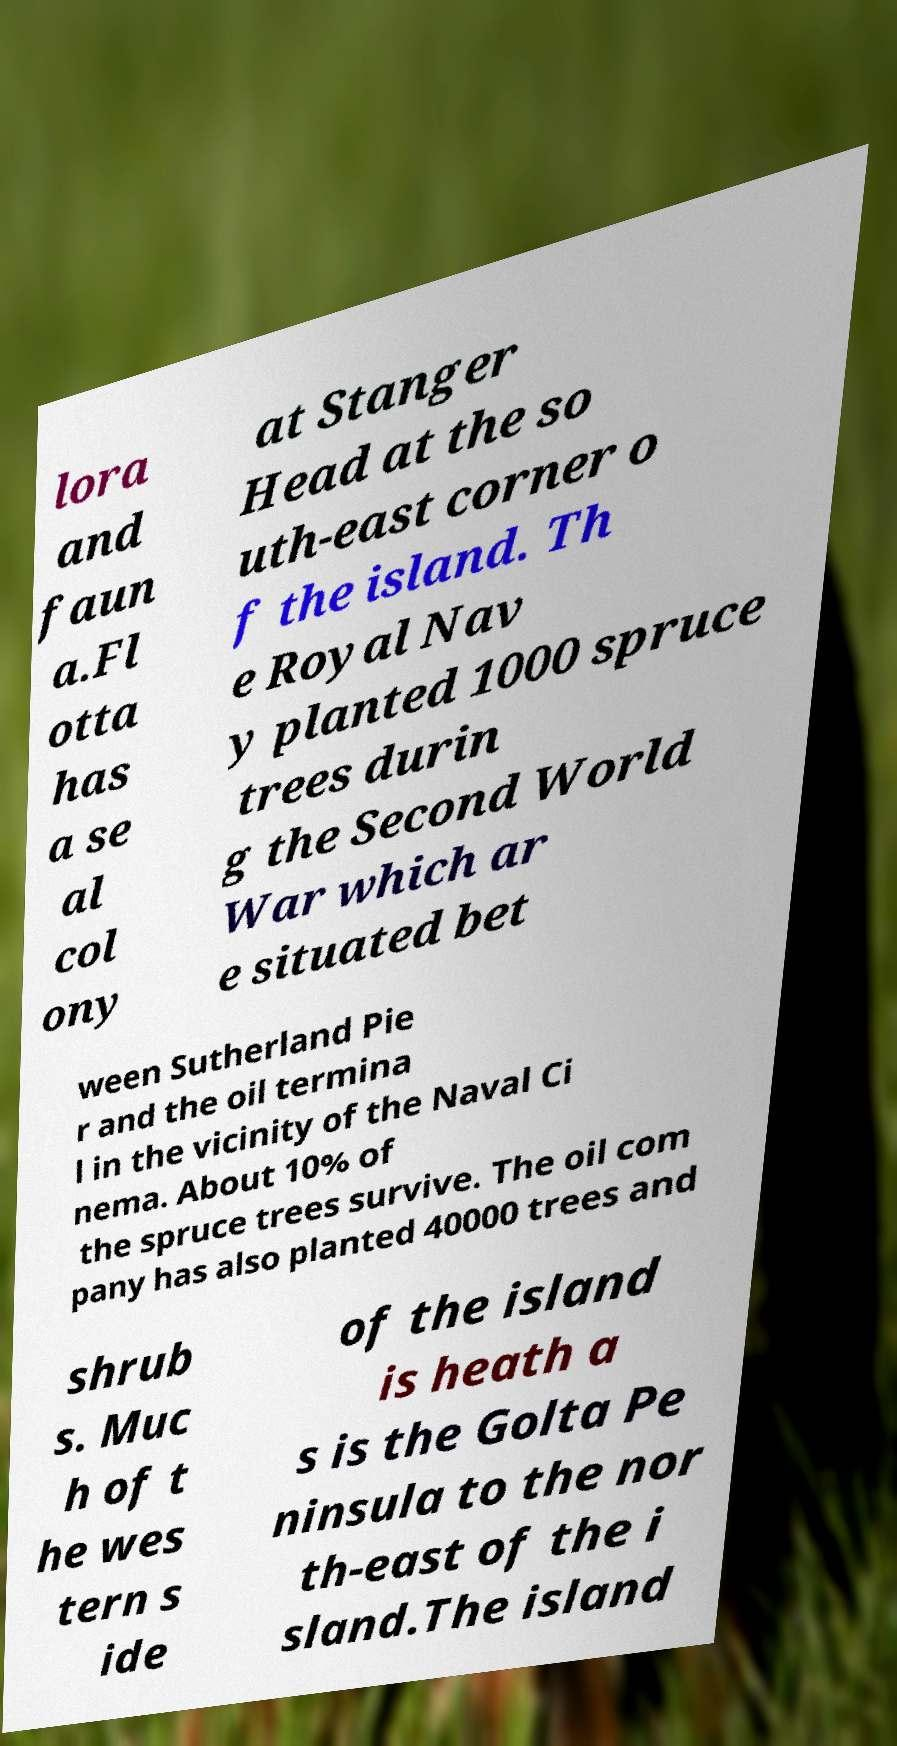I need the written content from this picture converted into text. Can you do that? lora and faun a.Fl otta has a se al col ony at Stanger Head at the so uth-east corner o f the island. Th e Royal Nav y planted 1000 spruce trees durin g the Second World War which ar e situated bet ween Sutherland Pie r and the oil termina l in the vicinity of the Naval Ci nema. About 10% of the spruce trees survive. The oil com pany has also planted 40000 trees and shrub s. Muc h of t he wes tern s ide of the island is heath a s is the Golta Pe ninsula to the nor th-east of the i sland.The island 